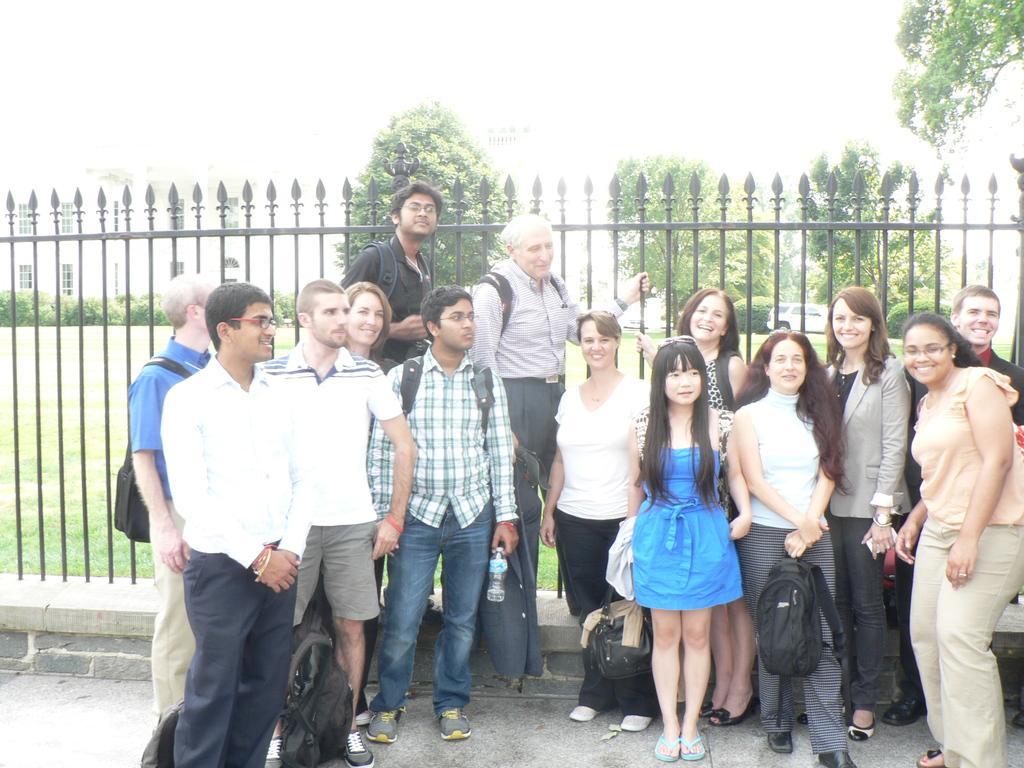How would you summarize this image in a sentence or two? As we can see in the image there are group of people standing, fence, grass, trees and building. 